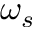<formula> <loc_0><loc_0><loc_500><loc_500>\omega _ { s }</formula> 